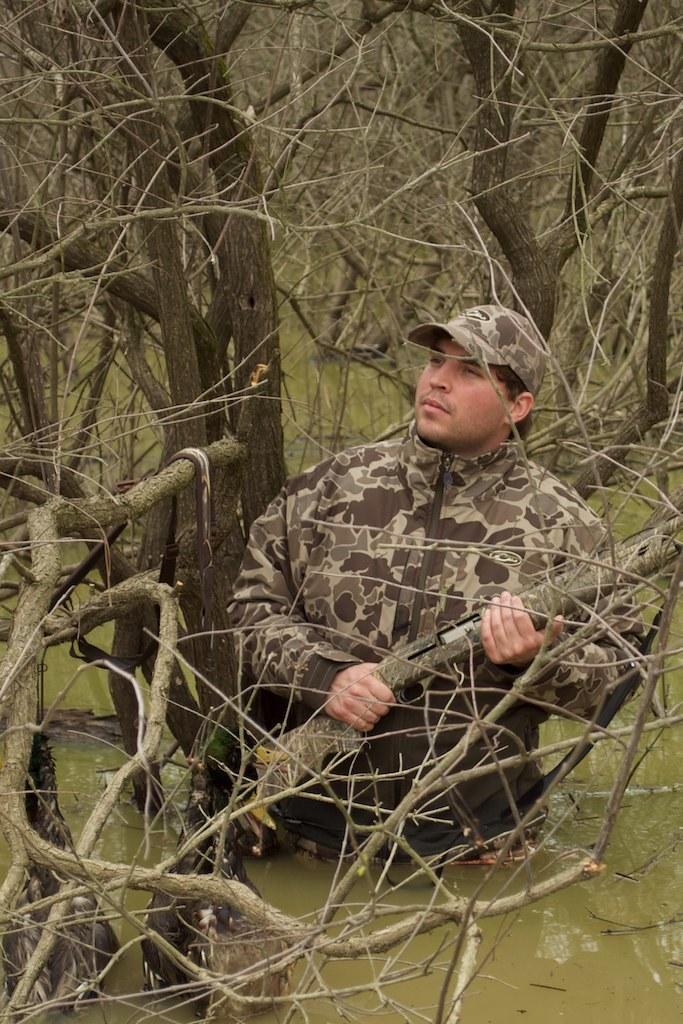In one or two sentences, can you explain what this image depicts? In this picture I can see a man is standing in the water and holding a gun in the hand. The man is wearing a cap and a uniform. In the background I can see trees and water. 